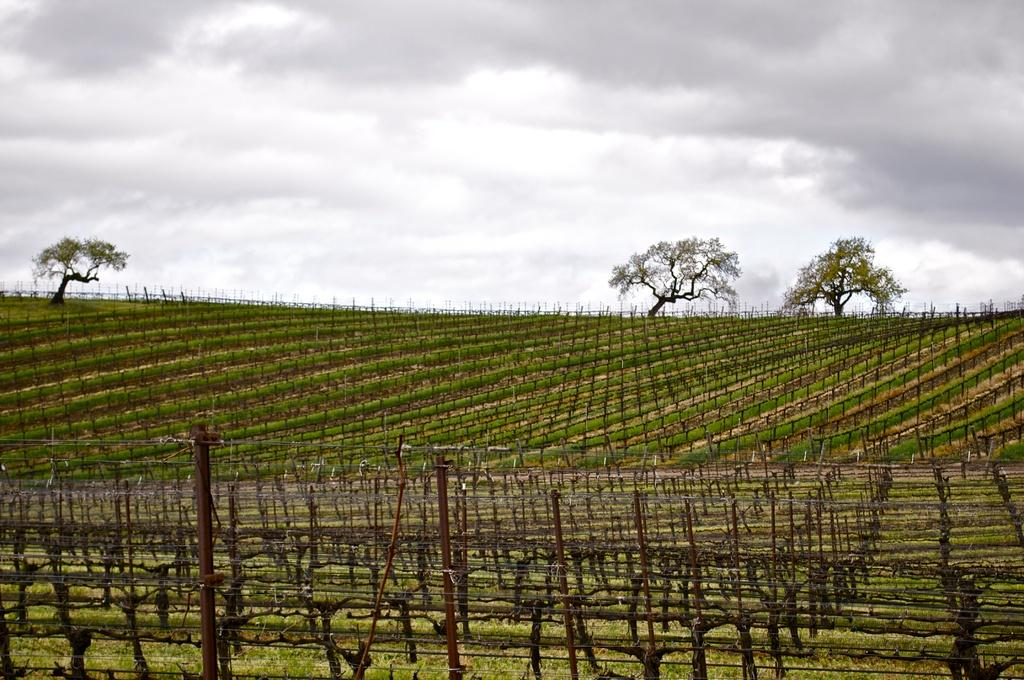What type of vegetation can be seen in the image? There are trees in the image. What is on the ground in the image? There is grass on the ground in the image. What part of the natural environment is visible in the image? The sky is visible in the image. What is the average income of the trees in the image? Trees do not have an income, so this question cannot be answered. 